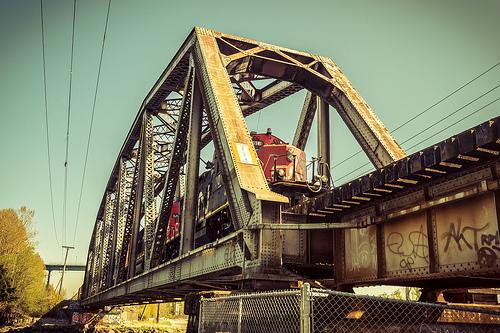Based on the image, can you describe the atmosphere and emotions it evokes? The image has a combination of industrial and natural elements, evoking a sense of curiosity and exploration, with an underlying feeling of nostalgia and tension between the old and the new. What type of art can be found on the bridge's side, and what is its color? There is graffiti on the bridge's side, and the words are written in black color. In the image, what are the physical characteristics of the bridge mentioned in the captions? The bridge is tall and metallic, with graffiti on its side, and a chain linked fence located below it. Provide a short description of the main focus in this image. A red train is crossing over a tall metallic bridge with graffiti on its side, surrounded by trees and a clear blue sky. Can you count how many trees are present in the image and describe their position? There are several trees, and they are located on the side of the road and beneath the bridge. Identify and describe any environmental features present in the image. There is a group of green trees beside the road, a clear blue sky, and some overhanging power cables. What is the color of the train, and what is it doing in the image? The train is red in color and it is crossing a bridge. Describe any lighting elements, and their locations, in the scene. The front headlights of the train are located at its front, with a red light on the train's roof, and the light pole with wires is near the trees. How many distinct objects can you identify in the image, and what are their components? There are 12 objects: a tall bridge, tarn yellow background, metallic walls, scrubbed words, green trees, black words, clear dull blue sky, red train head, white paper, graffiti, electrical posts, and metal fences. What are the main components in the image interacting, and how are they interacting with each other? The red train is interacting with the tall metallic bridge by crossing it, and the trees are interacting with the train and bridge by being located close to or under them. 